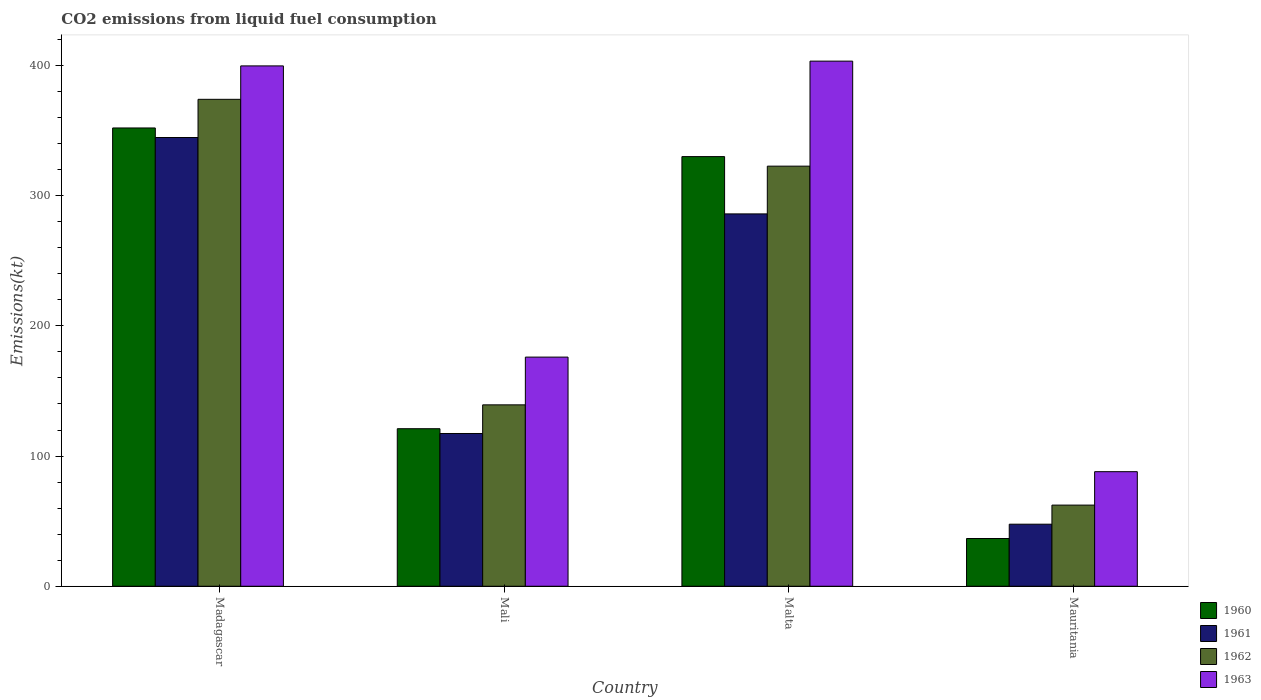How many different coloured bars are there?
Provide a succinct answer. 4. How many groups of bars are there?
Provide a succinct answer. 4. Are the number of bars on each tick of the X-axis equal?
Offer a very short reply. Yes. How many bars are there on the 1st tick from the left?
Your answer should be very brief. 4. How many bars are there on the 3rd tick from the right?
Offer a terse response. 4. What is the label of the 4th group of bars from the left?
Offer a terse response. Mauritania. In how many cases, is the number of bars for a given country not equal to the number of legend labels?
Your response must be concise. 0. What is the amount of CO2 emitted in 1963 in Mali?
Offer a terse response. 176.02. Across all countries, what is the maximum amount of CO2 emitted in 1963?
Give a very brief answer. 403.37. Across all countries, what is the minimum amount of CO2 emitted in 1963?
Your answer should be compact. 88.01. In which country was the amount of CO2 emitted in 1962 maximum?
Provide a succinct answer. Madagascar. In which country was the amount of CO2 emitted in 1963 minimum?
Ensure brevity in your answer.  Mauritania. What is the total amount of CO2 emitted in 1960 in the graph?
Your answer should be compact. 839.74. What is the difference between the amount of CO2 emitted in 1962 in Mali and that in Mauritania?
Your answer should be very brief. 77.01. What is the difference between the amount of CO2 emitted in 1960 in Madagascar and the amount of CO2 emitted in 1961 in Malta?
Provide a succinct answer. 66.01. What is the average amount of CO2 emitted in 1962 per country?
Provide a short and direct response. 224.6. What is the difference between the amount of CO2 emitted of/in 1961 and amount of CO2 emitted of/in 1963 in Mauritania?
Provide a succinct answer. -40.34. In how many countries, is the amount of CO2 emitted in 1963 greater than 220 kt?
Give a very brief answer. 2. What is the ratio of the amount of CO2 emitted in 1963 in Mali to that in Mauritania?
Give a very brief answer. 2. Is the difference between the amount of CO2 emitted in 1961 in Mali and Malta greater than the difference between the amount of CO2 emitted in 1963 in Mali and Malta?
Offer a terse response. Yes. What is the difference between the highest and the second highest amount of CO2 emitted in 1963?
Your answer should be very brief. -227.35. What is the difference between the highest and the lowest amount of CO2 emitted in 1960?
Offer a very short reply. 315.36. Is the sum of the amount of CO2 emitted in 1961 in Malta and Mauritania greater than the maximum amount of CO2 emitted in 1962 across all countries?
Your response must be concise. No. Is it the case that in every country, the sum of the amount of CO2 emitted in 1961 and amount of CO2 emitted in 1962 is greater than the amount of CO2 emitted in 1963?
Your answer should be very brief. Yes. How many bars are there?
Your response must be concise. 16. Are all the bars in the graph horizontal?
Provide a succinct answer. No. How many countries are there in the graph?
Make the answer very short. 4. What is the difference between two consecutive major ticks on the Y-axis?
Offer a very short reply. 100. Does the graph contain any zero values?
Ensure brevity in your answer.  No. Does the graph contain grids?
Provide a short and direct response. No. Where does the legend appear in the graph?
Give a very brief answer. Bottom right. How are the legend labels stacked?
Provide a succinct answer. Vertical. What is the title of the graph?
Provide a succinct answer. CO2 emissions from liquid fuel consumption. Does "2007" appear as one of the legend labels in the graph?
Your response must be concise. No. What is the label or title of the Y-axis?
Offer a very short reply. Emissions(kt). What is the Emissions(kt) in 1960 in Madagascar?
Give a very brief answer. 352.03. What is the Emissions(kt) of 1961 in Madagascar?
Provide a short and direct response. 344.7. What is the Emissions(kt) of 1962 in Madagascar?
Give a very brief answer. 374.03. What is the Emissions(kt) in 1963 in Madagascar?
Your answer should be very brief. 399.7. What is the Emissions(kt) in 1960 in Mali?
Give a very brief answer. 121.01. What is the Emissions(kt) in 1961 in Mali?
Provide a short and direct response. 117.34. What is the Emissions(kt) in 1962 in Mali?
Offer a very short reply. 139.35. What is the Emissions(kt) of 1963 in Mali?
Provide a succinct answer. 176.02. What is the Emissions(kt) in 1960 in Malta?
Your response must be concise. 330.03. What is the Emissions(kt) of 1961 in Malta?
Provide a short and direct response. 286.03. What is the Emissions(kt) of 1962 in Malta?
Offer a very short reply. 322.7. What is the Emissions(kt) of 1963 in Malta?
Offer a terse response. 403.37. What is the Emissions(kt) in 1960 in Mauritania?
Provide a succinct answer. 36.67. What is the Emissions(kt) of 1961 in Mauritania?
Offer a terse response. 47.67. What is the Emissions(kt) in 1962 in Mauritania?
Offer a very short reply. 62.34. What is the Emissions(kt) of 1963 in Mauritania?
Provide a short and direct response. 88.01. Across all countries, what is the maximum Emissions(kt) in 1960?
Keep it short and to the point. 352.03. Across all countries, what is the maximum Emissions(kt) in 1961?
Keep it short and to the point. 344.7. Across all countries, what is the maximum Emissions(kt) in 1962?
Offer a terse response. 374.03. Across all countries, what is the maximum Emissions(kt) in 1963?
Keep it short and to the point. 403.37. Across all countries, what is the minimum Emissions(kt) of 1960?
Provide a short and direct response. 36.67. Across all countries, what is the minimum Emissions(kt) of 1961?
Offer a terse response. 47.67. Across all countries, what is the minimum Emissions(kt) of 1962?
Keep it short and to the point. 62.34. Across all countries, what is the minimum Emissions(kt) of 1963?
Provide a succinct answer. 88.01. What is the total Emissions(kt) in 1960 in the graph?
Provide a succinct answer. 839.74. What is the total Emissions(kt) of 1961 in the graph?
Provide a short and direct response. 795.74. What is the total Emissions(kt) in 1962 in the graph?
Provide a succinct answer. 898.41. What is the total Emissions(kt) of 1963 in the graph?
Make the answer very short. 1067.1. What is the difference between the Emissions(kt) in 1960 in Madagascar and that in Mali?
Offer a very short reply. 231.02. What is the difference between the Emissions(kt) of 1961 in Madagascar and that in Mali?
Keep it short and to the point. 227.35. What is the difference between the Emissions(kt) of 1962 in Madagascar and that in Mali?
Keep it short and to the point. 234.69. What is the difference between the Emissions(kt) of 1963 in Madagascar and that in Mali?
Provide a succinct answer. 223.69. What is the difference between the Emissions(kt) in 1960 in Madagascar and that in Malta?
Your answer should be compact. 22. What is the difference between the Emissions(kt) of 1961 in Madagascar and that in Malta?
Provide a short and direct response. 58.67. What is the difference between the Emissions(kt) of 1962 in Madagascar and that in Malta?
Your response must be concise. 51.34. What is the difference between the Emissions(kt) in 1963 in Madagascar and that in Malta?
Ensure brevity in your answer.  -3.67. What is the difference between the Emissions(kt) in 1960 in Madagascar and that in Mauritania?
Offer a terse response. 315.36. What is the difference between the Emissions(kt) in 1961 in Madagascar and that in Mauritania?
Offer a terse response. 297.03. What is the difference between the Emissions(kt) of 1962 in Madagascar and that in Mauritania?
Your answer should be compact. 311.69. What is the difference between the Emissions(kt) of 1963 in Madagascar and that in Mauritania?
Your answer should be compact. 311.69. What is the difference between the Emissions(kt) in 1960 in Mali and that in Malta?
Provide a succinct answer. -209.02. What is the difference between the Emissions(kt) of 1961 in Mali and that in Malta?
Offer a terse response. -168.68. What is the difference between the Emissions(kt) in 1962 in Mali and that in Malta?
Make the answer very short. -183.35. What is the difference between the Emissions(kt) in 1963 in Mali and that in Malta?
Offer a very short reply. -227.35. What is the difference between the Emissions(kt) of 1960 in Mali and that in Mauritania?
Your response must be concise. 84.34. What is the difference between the Emissions(kt) in 1961 in Mali and that in Mauritania?
Your answer should be very brief. 69.67. What is the difference between the Emissions(kt) in 1962 in Mali and that in Mauritania?
Provide a succinct answer. 77.01. What is the difference between the Emissions(kt) in 1963 in Mali and that in Mauritania?
Offer a terse response. 88.01. What is the difference between the Emissions(kt) of 1960 in Malta and that in Mauritania?
Keep it short and to the point. 293.36. What is the difference between the Emissions(kt) in 1961 in Malta and that in Mauritania?
Your answer should be very brief. 238.35. What is the difference between the Emissions(kt) of 1962 in Malta and that in Mauritania?
Your response must be concise. 260.36. What is the difference between the Emissions(kt) of 1963 in Malta and that in Mauritania?
Offer a terse response. 315.36. What is the difference between the Emissions(kt) of 1960 in Madagascar and the Emissions(kt) of 1961 in Mali?
Your answer should be very brief. 234.69. What is the difference between the Emissions(kt) in 1960 in Madagascar and the Emissions(kt) in 1962 in Mali?
Make the answer very short. 212.69. What is the difference between the Emissions(kt) of 1960 in Madagascar and the Emissions(kt) of 1963 in Mali?
Provide a short and direct response. 176.02. What is the difference between the Emissions(kt) of 1961 in Madagascar and the Emissions(kt) of 1962 in Mali?
Give a very brief answer. 205.35. What is the difference between the Emissions(kt) of 1961 in Madagascar and the Emissions(kt) of 1963 in Mali?
Provide a short and direct response. 168.68. What is the difference between the Emissions(kt) in 1962 in Madagascar and the Emissions(kt) in 1963 in Mali?
Your answer should be very brief. 198.02. What is the difference between the Emissions(kt) of 1960 in Madagascar and the Emissions(kt) of 1961 in Malta?
Ensure brevity in your answer.  66.01. What is the difference between the Emissions(kt) in 1960 in Madagascar and the Emissions(kt) in 1962 in Malta?
Ensure brevity in your answer.  29.34. What is the difference between the Emissions(kt) of 1960 in Madagascar and the Emissions(kt) of 1963 in Malta?
Provide a succinct answer. -51.34. What is the difference between the Emissions(kt) in 1961 in Madagascar and the Emissions(kt) in 1962 in Malta?
Ensure brevity in your answer.  22. What is the difference between the Emissions(kt) in 1961 in Madagascar and the Emissions(kt) in 1963 in Malta?
Keep it short and to the point. -58.67. What is the difference between the Emissions(kt) of 1962 in Madagascar and the Emissions(kt) of 1963 in Malta?
Make the answer very short. -29.34. What is the difference between the Emissions(kt) in 1960 in Madagascar and the Emissions(kt) in 1961 in Mauritania?
Provide a short and direct response. 304.36. What is the difference between the Emissions(kt) in 1960 in Madagascar and the Emissions(kt) in 1962 in Mauritania?
Offer a very short reply. 289.69. What is the difference between the Emissions(kt) in 1960 in Madagascar and the Emissions(kt) in 1963 in Mauritania?
Your answer should be compact. 264.02. What is the difference between the Emissions(kt) of 1961 in Madagascar and the Emissions(kt) of 1962 in Mauritania?
Give a very brief answer. 282.36. What is the difference between the Emissions(kt) of 1961 in Madagascar and the Emissions(kt) of 1963 in Mauritania?
Your answer should be compact. 256.69. What is the difference between the Emissions(kt) in 1962 in Madagascar and the Emissions(kt) in 1963 in Mauritania?
Make the answer very short. 286.03. What is the difference between the Emissions(kt) of 1960 in Mali and the Emissions(kt) of 1961 in Malta?
Give a very brief answer. -165.01. What is the difference between the Emissions(kt) of 1960 in Mali and the Emissions(kt) of 1962 in Malta?
Make the answer very short. -201.69. What is the difference between the Emissions(kt) of 1960 in Mali and the Emissions(kt) of 1963 in Malta?
Your answer should be very brief. -282.36. What is the difference between the Emissions(kt) of 1961 in Mali and the Emissions(kt) of 1962 in Malta?
Ensure brevity in your answer.  -205.35. What is the difference between the Emissions(kt) of 1961 in Mali and the Emissions(kt) of 1963 in Malta?
Provide a succinct answer. -286.03. What is the difference between the Emissions(kt) of 1962 in Mali and the Emissions(kt) of 1963 in Malta?
Offer a very short reply. -264.02. What is the difference between the Emissions(kt) in 1960 in Mali and the Emissions(kt) in 1961 in Mauritania?
Give a very brief answer. 73.34. What is the difference between the Emissions(kt) in 1960 in Mali and the Emissions(kt) in 1962 in Mauritania?
Ensure brevity in your answer.  58.67. What is the difference between the Emissions(kt) of 1960 in Mali and the Emissions(kt) of 1963 in Mauritania?
Provide a short and direct response. 33. What is the difference between the Emissions(kt) of 1961 in Mali and the Emissions(kt) of 1962 in Mauritania?
Keep it short and to the point. 55.01. What is the difference between the Emissions(kt) of 1961 in Mali and the Emissions(kt) of 1963 in Mauritania?
Offer a very short reply. 29.34. What is the difference between the Emissions(kt) of 1962 in Mali and the Emissions(kt) of 1963 in Mauritania?
Provide a succinct answer. 51.34. What is the difference between the Emissions(kt) in 1960 in Malta and the Emissions(kt) in 1961 in Mauritania?
Provide a short and direct response. 282.36. What is the difference between the Emissions(kt) in 1960 in Malta and the Emissions(kt) in 1962 in Mauritania?
Your answer should be very brief. 267.69. What is the difference between the Emissions(kt) in 1960 in Malta and the Emissions(kt) in 1963 in Mauritania?
Your answer should be very brief. 242.02. What is the difference between the Emissions(kt) of 1961 in Malta and the Emissions(kt) of 1962 in Mauritania?
Keep it short and to the point. 223.69. What is the difference between the Emissions(kt) in 1961 in Malta and the Emissions(kt) in 1963 in Mauritania?
Your answer should be compact. 198.02. What is the difference between the Emissions(kt) in 1962 in Malta and the Emissions(kt) in 1963 in Mauritania?
Your answer should be compact. 234.69. What is the average Emissions(kt) in 1960 per country?
Provide a short and direct response. 209.94. What is the average Emissions(kt) in 1961 per country?
Provide a succinct answer. 198.93. What is the average Emissions(kt) in 1962 per country?
Your answer should be very brief. 224.6. What is the average Emissions(kt) of 1963 per country?
Provide a succinct answer. 266.77. What is the difference between the Emissions(kt) in 1960 and Emissions(kt) in 1961 in Madagascar?
Your answer should be compact. 7.33. What is the difference between the Emissions(kt) in 1960 and Emissions(kt) in 1962 in Madagascar?
Your answer should be very brief. -22. What is the difference between the Emissions(kt) in 1960 and Emissions(kt) in 1963 in Madagascar?
Your answer should be compact. -47.67. What is the difference between the Emissions(kt) in 1961 and Emissions(kt) in 1962 in Madagascar?
Keep it short and to the point. -29.34. What is the difference between the Emissions(kt) of 1961 and Emissions(kt) of 1963 in Madagascar?
Ensure brevity in your answer.  -55.01. What is the difference between the Emissions(kt) of 1962 and Emissions(kt) of 1963 in Madagascar?
Make the answer very short. -25.67. What is the difference between the Emissions(kt) of 1960 and Emissions(kt) of 1961 in Mali?
Give a very brief answer. 3.67. What is the difference between the Emissions(kt) of 1960 and Emissions(kt) of 1962 in Mali?
Offer a terse response. -18.34. What is the difference between the Emissions(kt) in 1960 and Emissions(kt) in 1963 in Mali?
Your answer should be compact. -55.01. What is the difference between the Emissions(kt) in 1961 and Emissions(kt) in 1962 in Mali?
Your answer should be compact. -22. What is the difference between the Emissions(kt) of 1961 and Emissions(kt) of 1963 in Mali?
Offer a very short reply. -58.67. What is the difference between the Emissions(kt) of 1962 and Emissions(kt) of 1963 in Mali?
Offer a terse response. -36.67. What is the difference between the Emissions(kt) of 1960 and Emissions(kt) of 1961 in Malta?
Ensure brevity in your answer.  44. What is the difference between the Emissions(kt) in 1960 and Emissions(kt) in 1962 in Malta?
Give a very brief answer. 7.33. What is the difference between the Emissions(kt) in 1960 and Emissions(kt) in 1963 in Malta?
Keep it short and to the point. -73.34. What is the difference between the Emissions(kt) of 1961 and Emissions(kt) of 1962 in Malta?
Offer a very short reply. -36.67. What is the difference between the Emissions(kt) of 1961 and Emissions(kt) of 1963 in Malta?
Ensure brevity in your answer.  -117.34. What is the difference between the Emissions(kt) in 1962 and Emissions(kt) in 1963 in Malta?
Make the answer very short. -80.67. What is the difference between the Emissions(kt) in 1960 and Emissions(kt) in 1961 in Mauritania?
Keep it short and to the point. -11. What is the difference between the Emissions(kt) of 1960 and Emissions(kt) of 1962 in Mauritania?
Offer a very short reply. -25.67. What is the difference between the Emissions(kt) of 1960 and Emissions(kt) of 1963 in Mauritania?
Your answer should be very brief. -51.34. What is the difference between the Emissions(kt) of 1961 and Emissions(kt) of 1962 in Mauritania?
Provide a short and direct response. -14.67. What is the difference between the Emissions(kt) in 1961 and Emissions(kt) in 1963 in Mauritania?
Ensure brevity in your answer.  -40.34. What is the difference between the Emissions(kt) in 1962 and Emissions(kt) in 1963 in Mauritania?
Your answer should be compact. -25.67. What is the ratio of the Emissions(kt) of 1960 in Madagascar to that in Mali?
Offer a very short reply. 2.91. What is the ratio of the Emissions(kt) of 1961 in Madagascar to that in Mali?
Ensure brevity in your answer.  2.94. What is the ratio of the Emissions(kt) of 1962 in Madagascar to that in Mali?
Provide a short and direct response. 2.68. What is the ratio of the Emissions(kt) in 1963 in Madagascar to that in Mali?
Your response must be concise. 2.27. What is the ratio of the Emissions(kt) in 1960 in Madagascar to that in Malta?
Your answer should be compact. 1.07. What is the ratio of the Emissions(kt) in 1961 in Madagascar to that in Malta?
Keep it short and to the point. 1.21. What is the ratio of the Emissions(kt) in 1962 in Madagascar to that in Malta?
Make the answer very short. 1.16. What is the ratio of the Emissions(kt) of 1963 in Madagascar to that in Malta?
Your answer should be compact. 0.99. What is the ratio of the Emissions(kt) of 1961 in Madagascar to that in Mauritania?
Make the answer very short. 7.23. What is the ratio of the Emissions(kt) in 1962 in Madagascar to that in Mauritania?
Make the answer very short. 6. What is the ratio of the Emissions(kt) in 1963 in Madagascar to that in Mauritania?
Your response must be concise. 4.54. What is the ratio of the Emissions(kt) of 1960 in Mali to that in Malta?
Give a very brief answer. 0.37. What is the ratio of the Emissions(kt) of 1961 in Mali to that in Malta?
Offer a terse response. 0.41. What is the ratio of the Emissions(kt) in 1962 in Mali to that in Malta?
Ensure brevity in your answer.  0.43. What is the ratio of the Emissions(kt) of 1963 in Mali to that in Malta?
Provide a succinct answer. 0.44. What is the ratio of the Emissions(kt) in 1960 in Mali to that in Mauritania?
Give a very brief answer. 3.3. What is the ratio of the Emissions(kt) in 1961 in Mali to that in Mauritania?
Offer a very short reply. 2.46. What is the ratio of the Emissions(kt) in 1962 in Mali to that in Mauritania?
Provide a succinct answer. 2.24. What is the ratio of the Emissions(kt) in 1960 in Malta to that in Mauritania?
Your answer should be very brief. 9. What is the ratio of the Emissions(kt) in 1962 in Malta to that in Mauritania?
Your answer should be very brief. 5.18. What is the ratio of the Emissions(kt) in 1963 in Malta to that in Mauritania?
Your answer should be compact. 4.58. What is the difference between the highest and the second highest Emissions(kt) in 1960?
Provide a succinct answer. 22. What is the difference between the highest and the second highest Emissions(kt) in 1961?
Your answer should be very brief. 58.67. What is the difference between the highest and the second highest Emissions(kt) in 1962?
Your answer should be very brief. 51.34. What is the difference between the highest and the second highest Emissions(kt) in 1963?
Provide a succinct answer. 3.67. What is the difference between the highest and the lowest Emissions(kt) of 1960?
Make the answer very short. 315.36. What is the difference between the highest and the lowest Emissions(kt) of 1961?
Offer a very short reply. 297.03. What is the difference between the highest and the lowest Emissions(kt) in 1962?
Your response must be concise. 311.69. What is the difference between the highest and the lowest Emissions(kt) in 1963?
Your answer should be very brief. 315.36. 